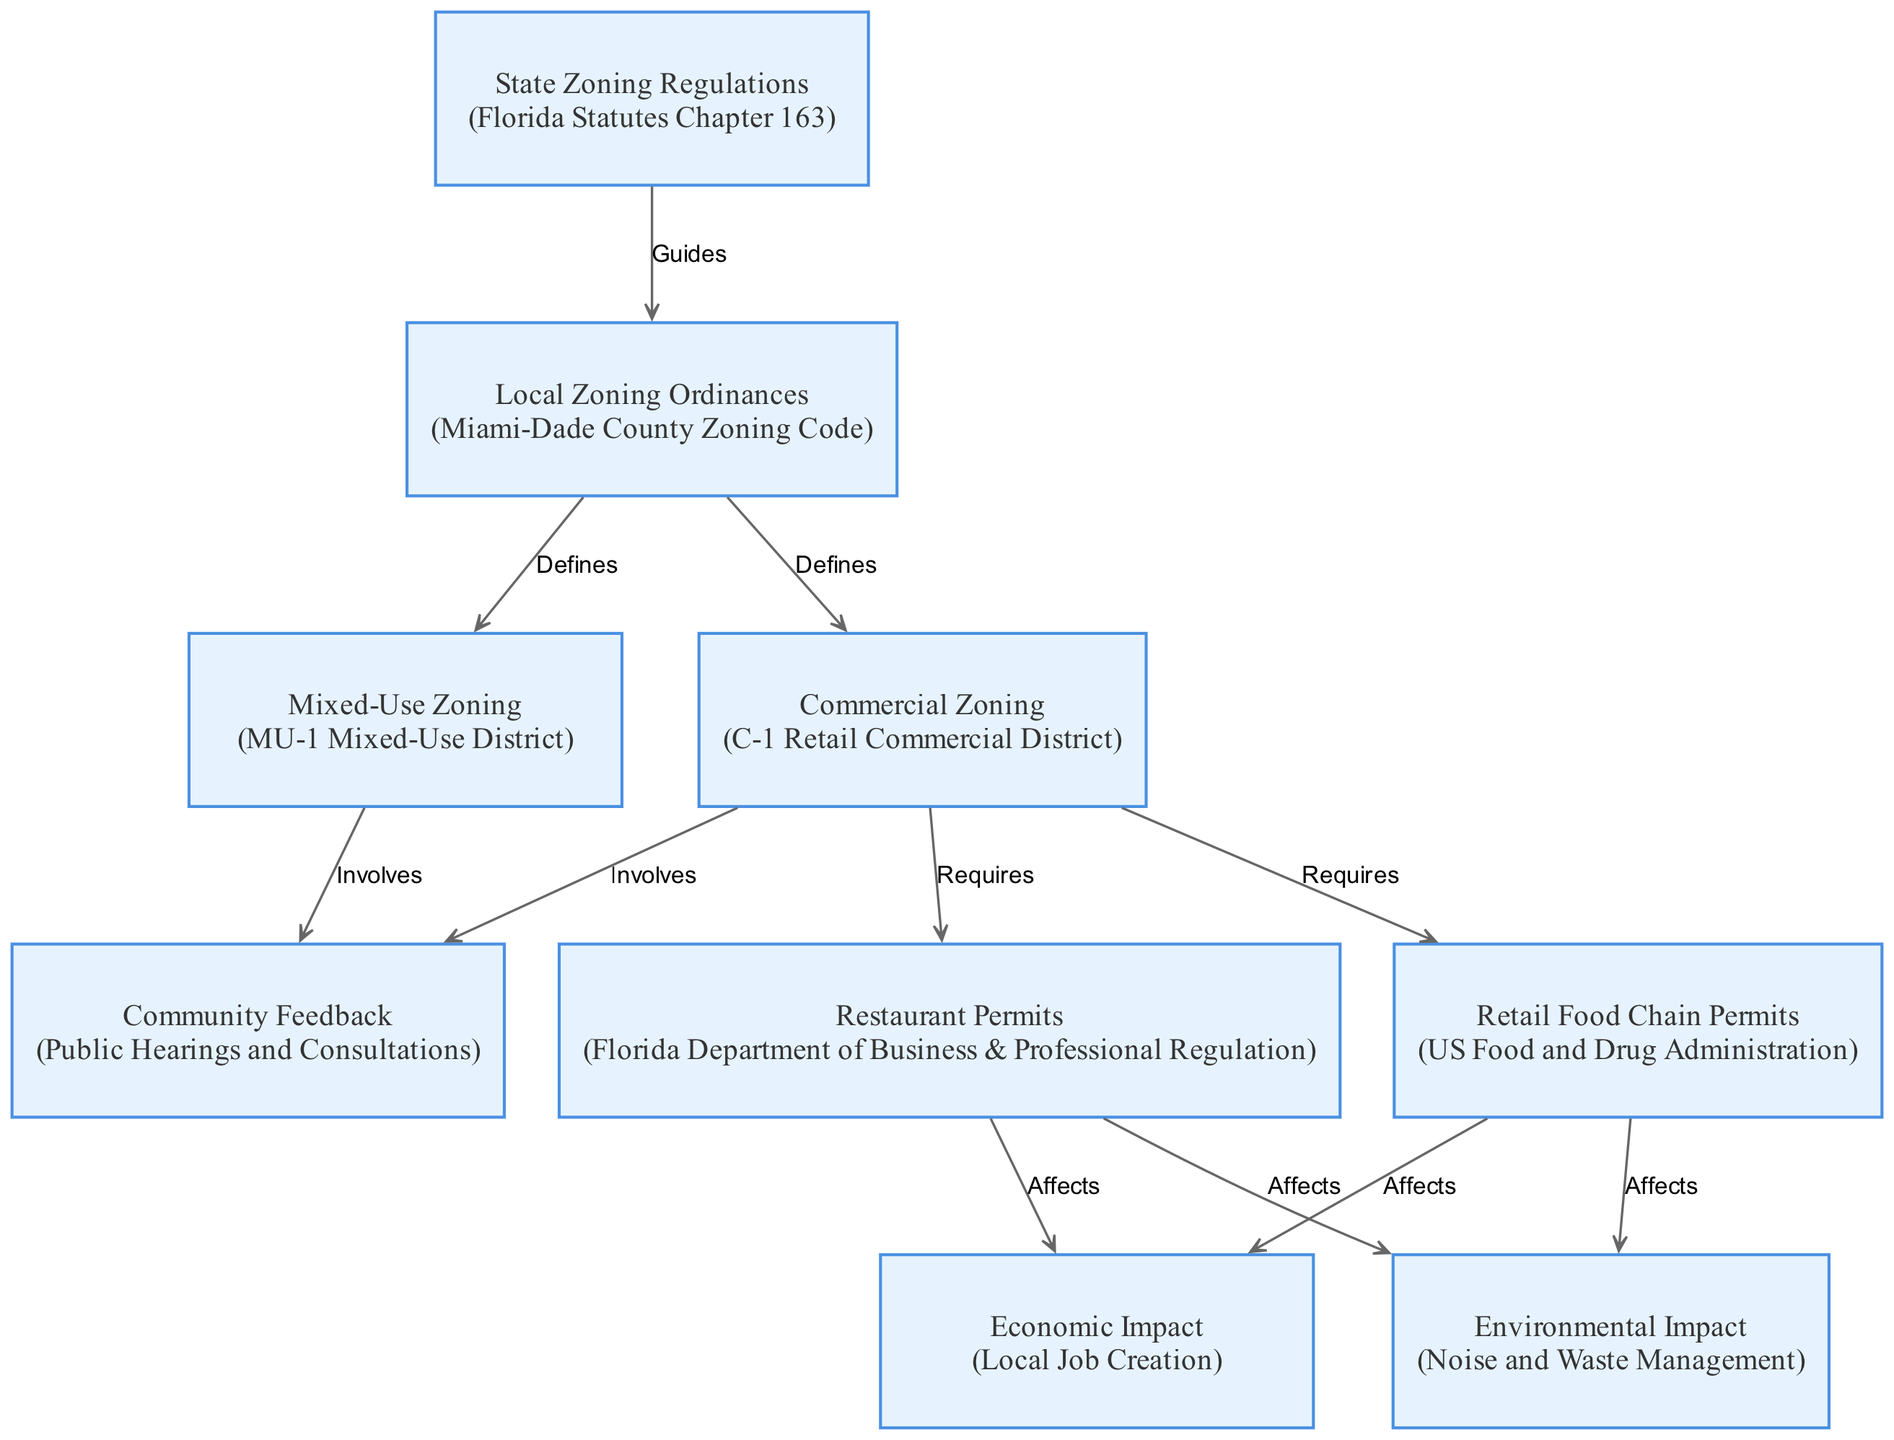What are the local zoning ordinances influenced by? The local zoning ordinances are influenced by state zoning regulations, which guide the local lawmakers in crafting specific ordinances for their regions. This relationship is represented by the edge labeled "Guides" connecting the nodes "State Zoning Regulations" and "Local Zoning Ordinances."
Answer: State zoning regulations How many types of zoning are defined by local zoning ordinances? The local zoning ordinances define two types of zoning: commercial zoning and mixed-use zoning, which are indicated by the edges labeled "Defines" connecting "Local Zoning Ordinances" to both "Commercial Zoning" and "Mixed-Use Zoning."
Answer: Two What type of zoning requires restaurant permits? Commercial zoning necessitates restaurant permits, as depicted in the diagram where "Commercial Zoning" directly connects to "Restaurant Permits" with an edge labeled "Requires."
Answer: Commercial zoning Which entity is responsible for restaurant permits? The Florida Department of Business & Professional Regulation is responsible for granting restaurant permits, as shown in the node "Restaurant Permits."
Answer: Florida Department of Business & Professional Regulation What are the effects of restaurant permits on the community? Restaurant permits affect the community primarily through local job creation and environmental impacts, such as noise and waste management. This is indicated by the edges labeled "Affects" connecting "Restaurant Permits" to both "Economic Impact" and "Environmental Impact."
Answer: Local job creation and environmental impacts Which node involves community feedback? Both commercial zoning and mixed-use zoning involve community feedback, as indicated by the edges labeled "Involves" connecting the nodes "Commercial Zoning" and "Mixed-Use Zoning" to "Community Feedback."
Answer: Commercial zoning and mixed-use zoning What impacts does mixed-use zoning have? Mixed-use zoning impacts community feedback, and this effect is illustrated by the "Involves" edge linking "Mixed-Use Zoning" to "Community Feedback."
Answer: Community feedback How many edges are there related to the economic impact? There are two edges related to the economic impact: one from "Restaurant Permits" to "Economic Impact" and another from "Retail Food Chain Permits" to "Economic Impact." This means the total is two edges affecting it.
Answer: Two 